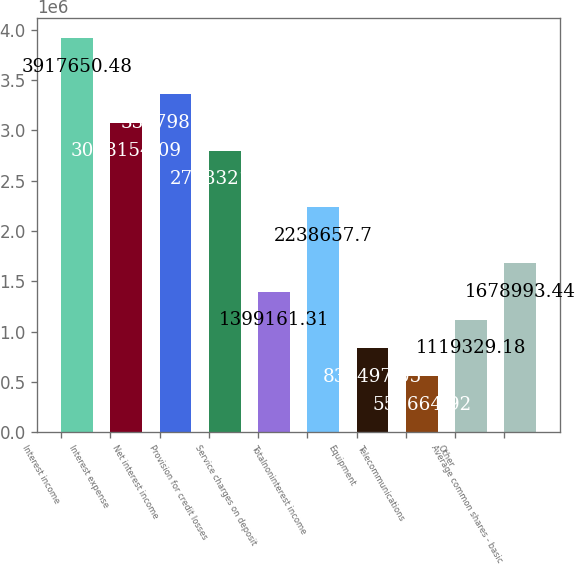Convert chart. <chart><loc_0><loc_0><loc_500><loc_500><bar_chart><fcel>Interest income<fcel>Interest expense<fcel>Net interest income<fcel>Provision for credit losses<fcel>Service charges on deposit<fcel>Totalnoninterest income<fcel>Equipment<fcel>Telecommunications<fcel>Other<fcel>Average common shares - basic<nl><fcel>3.91765e+06<fcel>3.07815e+06<fcel>3.35799e+06<fcel>2.79832e+06<fcel>1.39916e+06<fcel>2.23866e+06<fcel>839497<fcel>559665<fcel>1.11933e+06<fcel>1.67899e+06<nl></chart> 